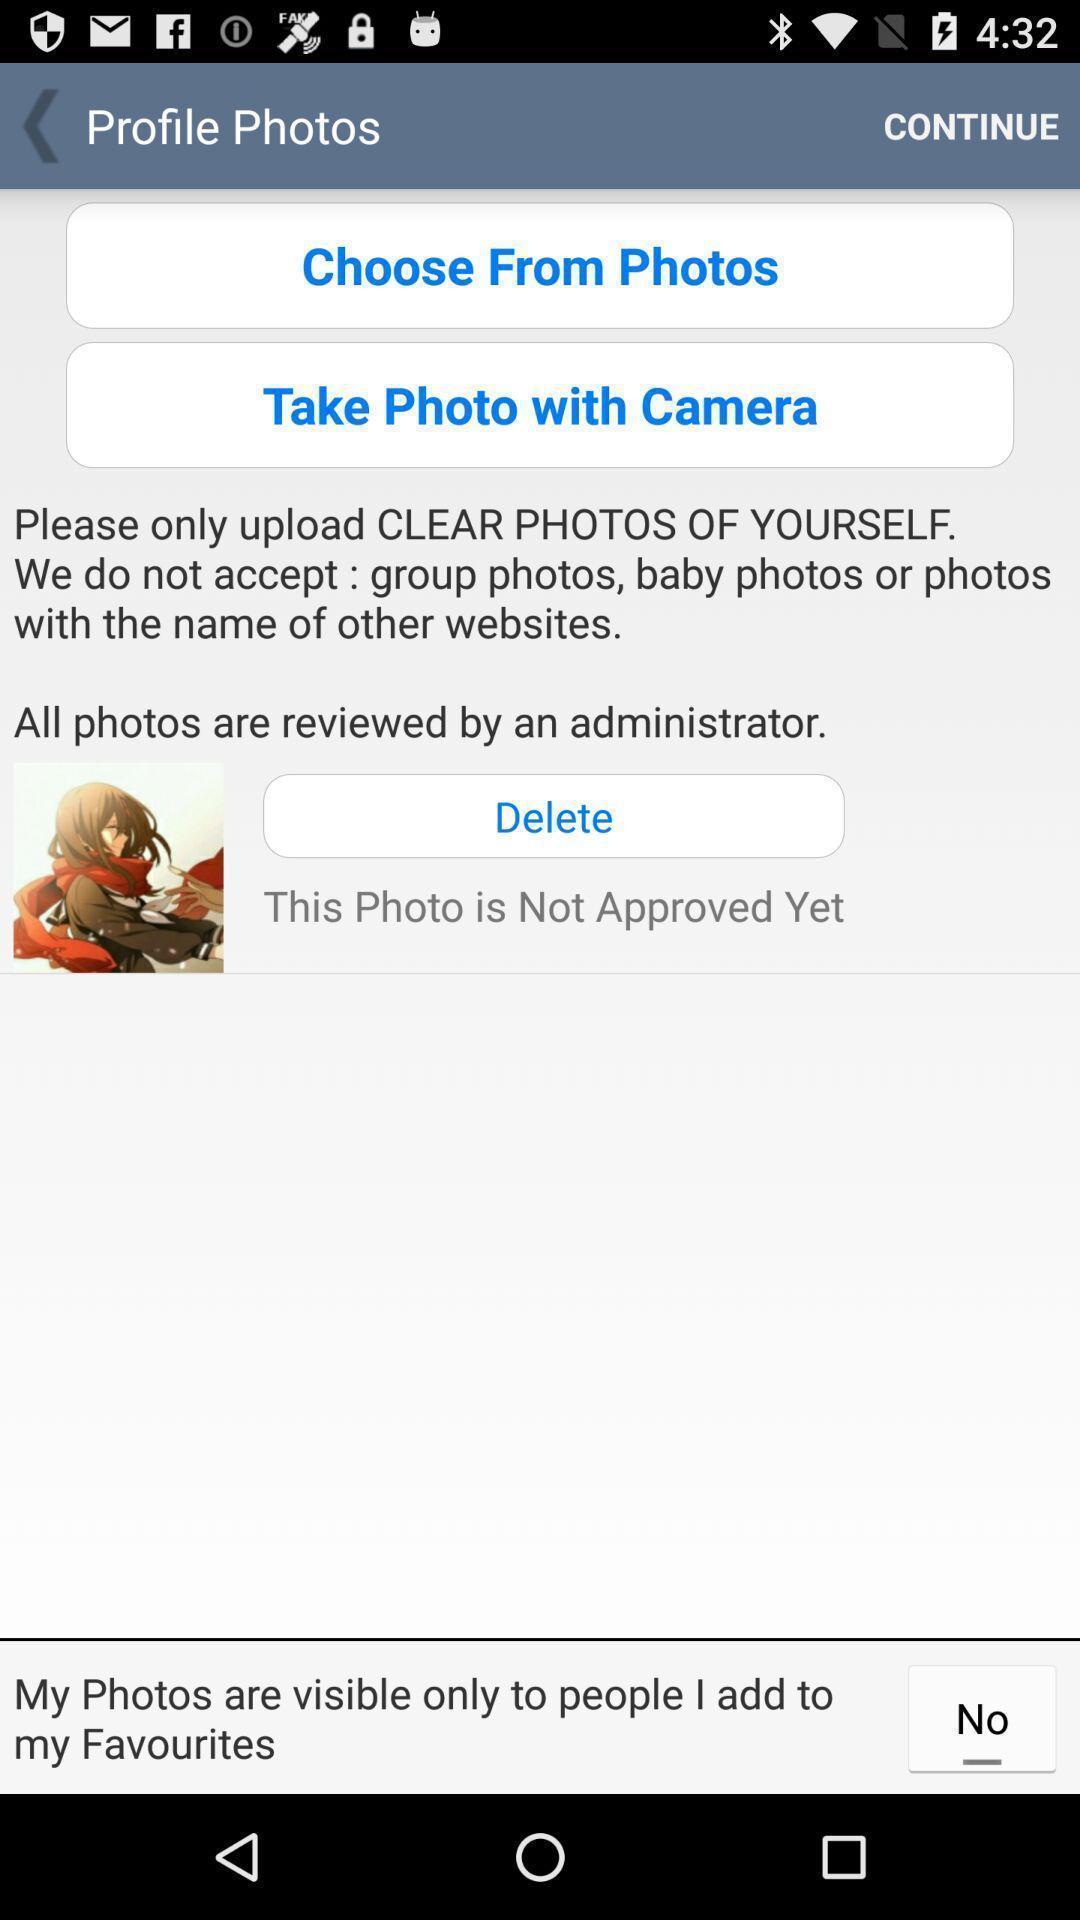Give me a summary of this screen capture. Setting up the profile picture. 